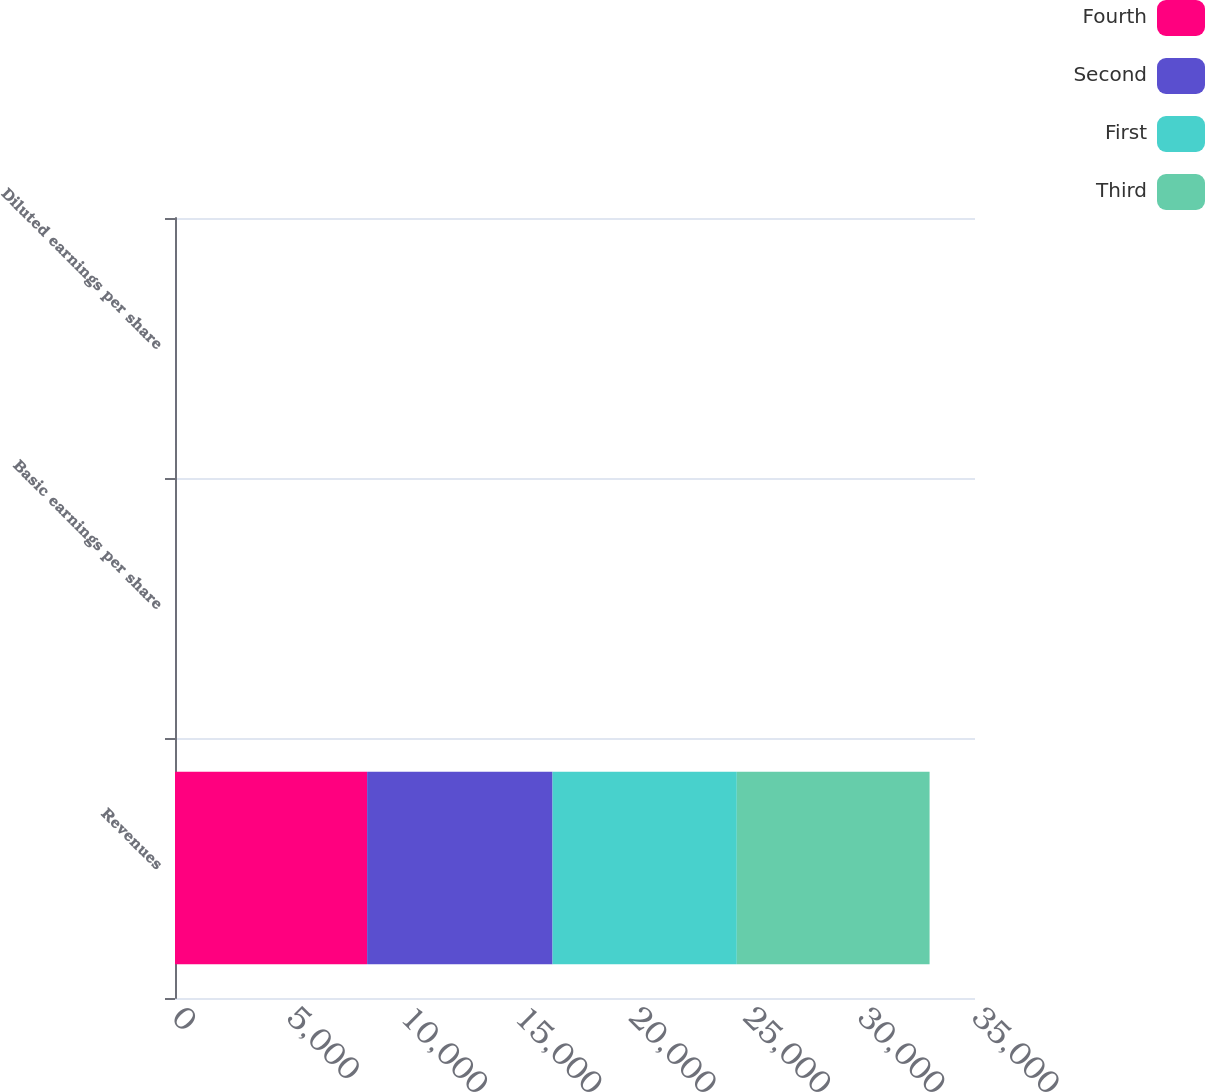Convert chart. <chart><loc_0><loc_0><loc_500><loc_500><stacked_bar_chart><ecel><fcel>Revenues<fcel>Basic earnings per share<fcel>Diluted earnings per share<nl><fcel>Fourth<fcel>8405<fcel>1.23<fcel>1.18<nl><fcel>Second<fcel>8112<fcel>0.89<fcel>0.85<nl><fcel>First<fcel>8062<fcel>0.82<fcel>0.78<nl><fcel>Third<fcel>8434<fcel>0.71<fcel>0.68<nl></chart> 